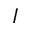<formula> <loc_0><loc_0><loc_500><loc_500>I</formula> 